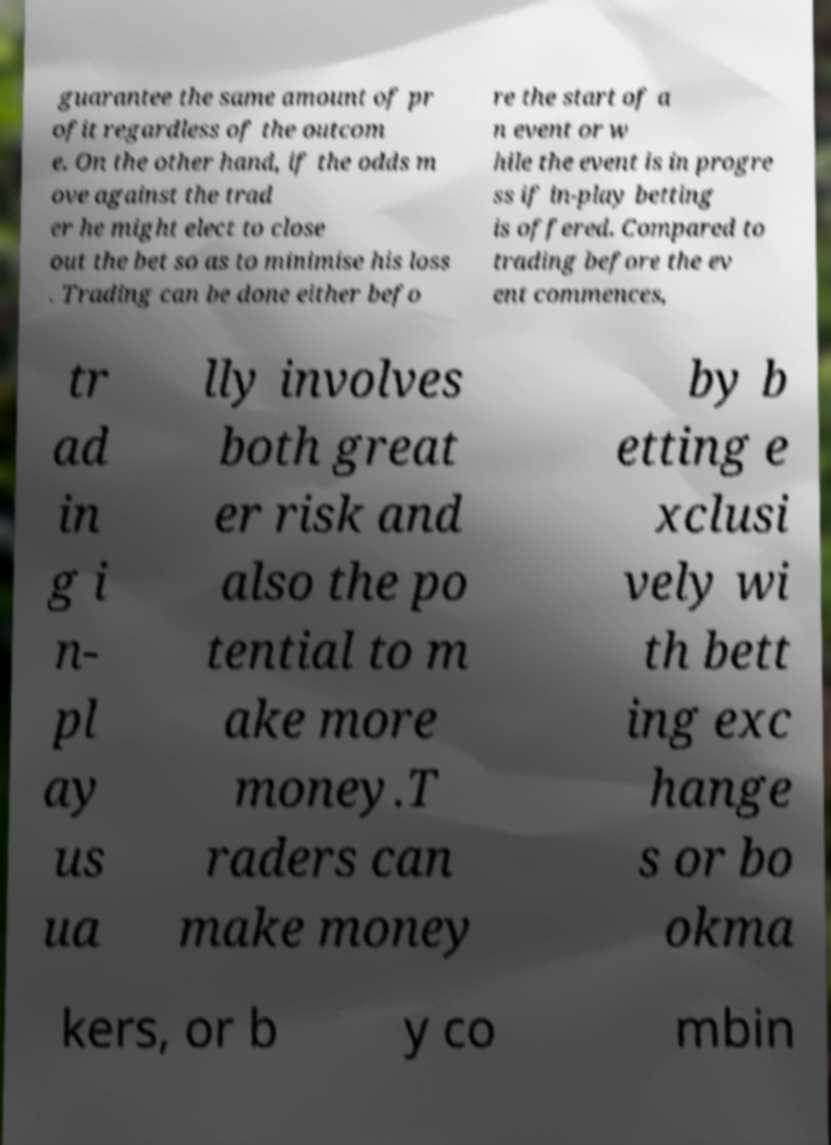There's text embedded in this image that I need extracted. Can you transcribe it verbatim? guarantee the same amount of pr ofit regardless of the outcom e. On the other hand, if the odds m ove against the trad er he might elect to close out the bet so as to minimise his loss . Trading can be done either befo re the start of a n event or w hile the event is in progre ss if in-play betting is offered. Compared to trading before the ev ent commences, tr ad in g i n- pl ay us ua lly involves both great er risk and also the po tential to m ake more money.T raders can make money by b etting e xclusi vely wi th bett ing exc hange s or bo okma kers, or b y co mbin 